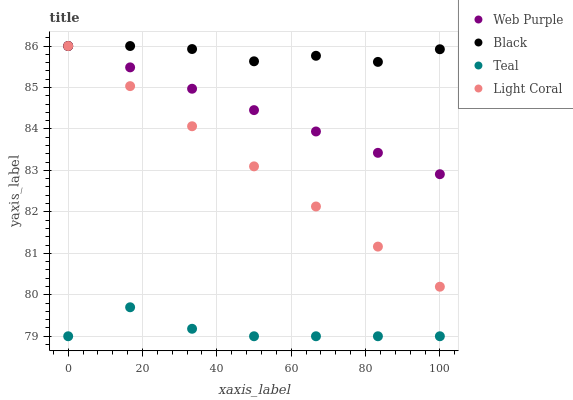Does Teal have the minimum area under the curve?
Answer yes or no. Yes. Does Black have the maximum area under the curve?
Answer yes or no. Yes. Does Web Purple have the minimum area under the curve?
Answer yes or no. No. Does Web Purple have the maximum area under the curve?
Answer yes or no. No. Is Web Purple the smoothest?
Answer yes or no. Yes. Is Teal the roughest?
Answer yes or no. Yes. Is Black the smoothest?
Answer yes or no. No. Is Black the roughest?
Answer yes or no. No. Does Teal have the lowest value?
Answer yes or no. Yes. Does Web Purple have the lowest value?
Answer yes or no. No. Does Black have the highest value?
Answer yes or no. Yes. Does Teal have the highest value?
Answer yes or no. No. Is Teal less than Light Coral?
Answer yes or no. Yes. Is Web Purple greater than Teal?
Answer yes or no. Yes. Does Black intersect Light Coral?
Answer yes or no. Yes. Is Black less than Light Coral?
Answer yes or no. No. Is Black greater than Light Coral?
Answer yes or no. No. Does Teal intersect Light Coral?
Answer yes or no. No. 